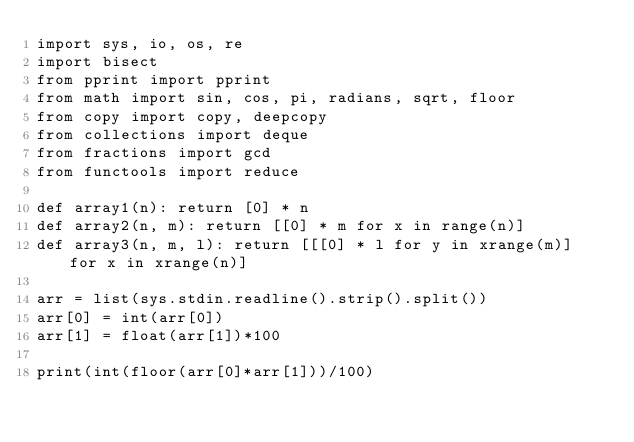Convert code to text. <code><loc_0><loc_0><loc_500><loc_500><_Python_>import sys, io, os, re
import bisect
from pprint import pprint
from math import sin, cos, pi, radians, sqrt, floor
from copy import copy, deepcopy
from collections import deque
from fractions import gcd
from functools import reduce

def array1(n): return [0] * n
def array2(n, m): return [[0] * m for x in range(n)]
def array3(n, m, l): return [[[0] * l for y in xrange(m)] for x in xrange(n)]

arr = list(sys.stdin.readline().strip().split())
arr[0] = int(arr[0])
arr[1] = float(arr[1])*100

print(int(floor(arr[0]*arr[1]))/100)
</code> 